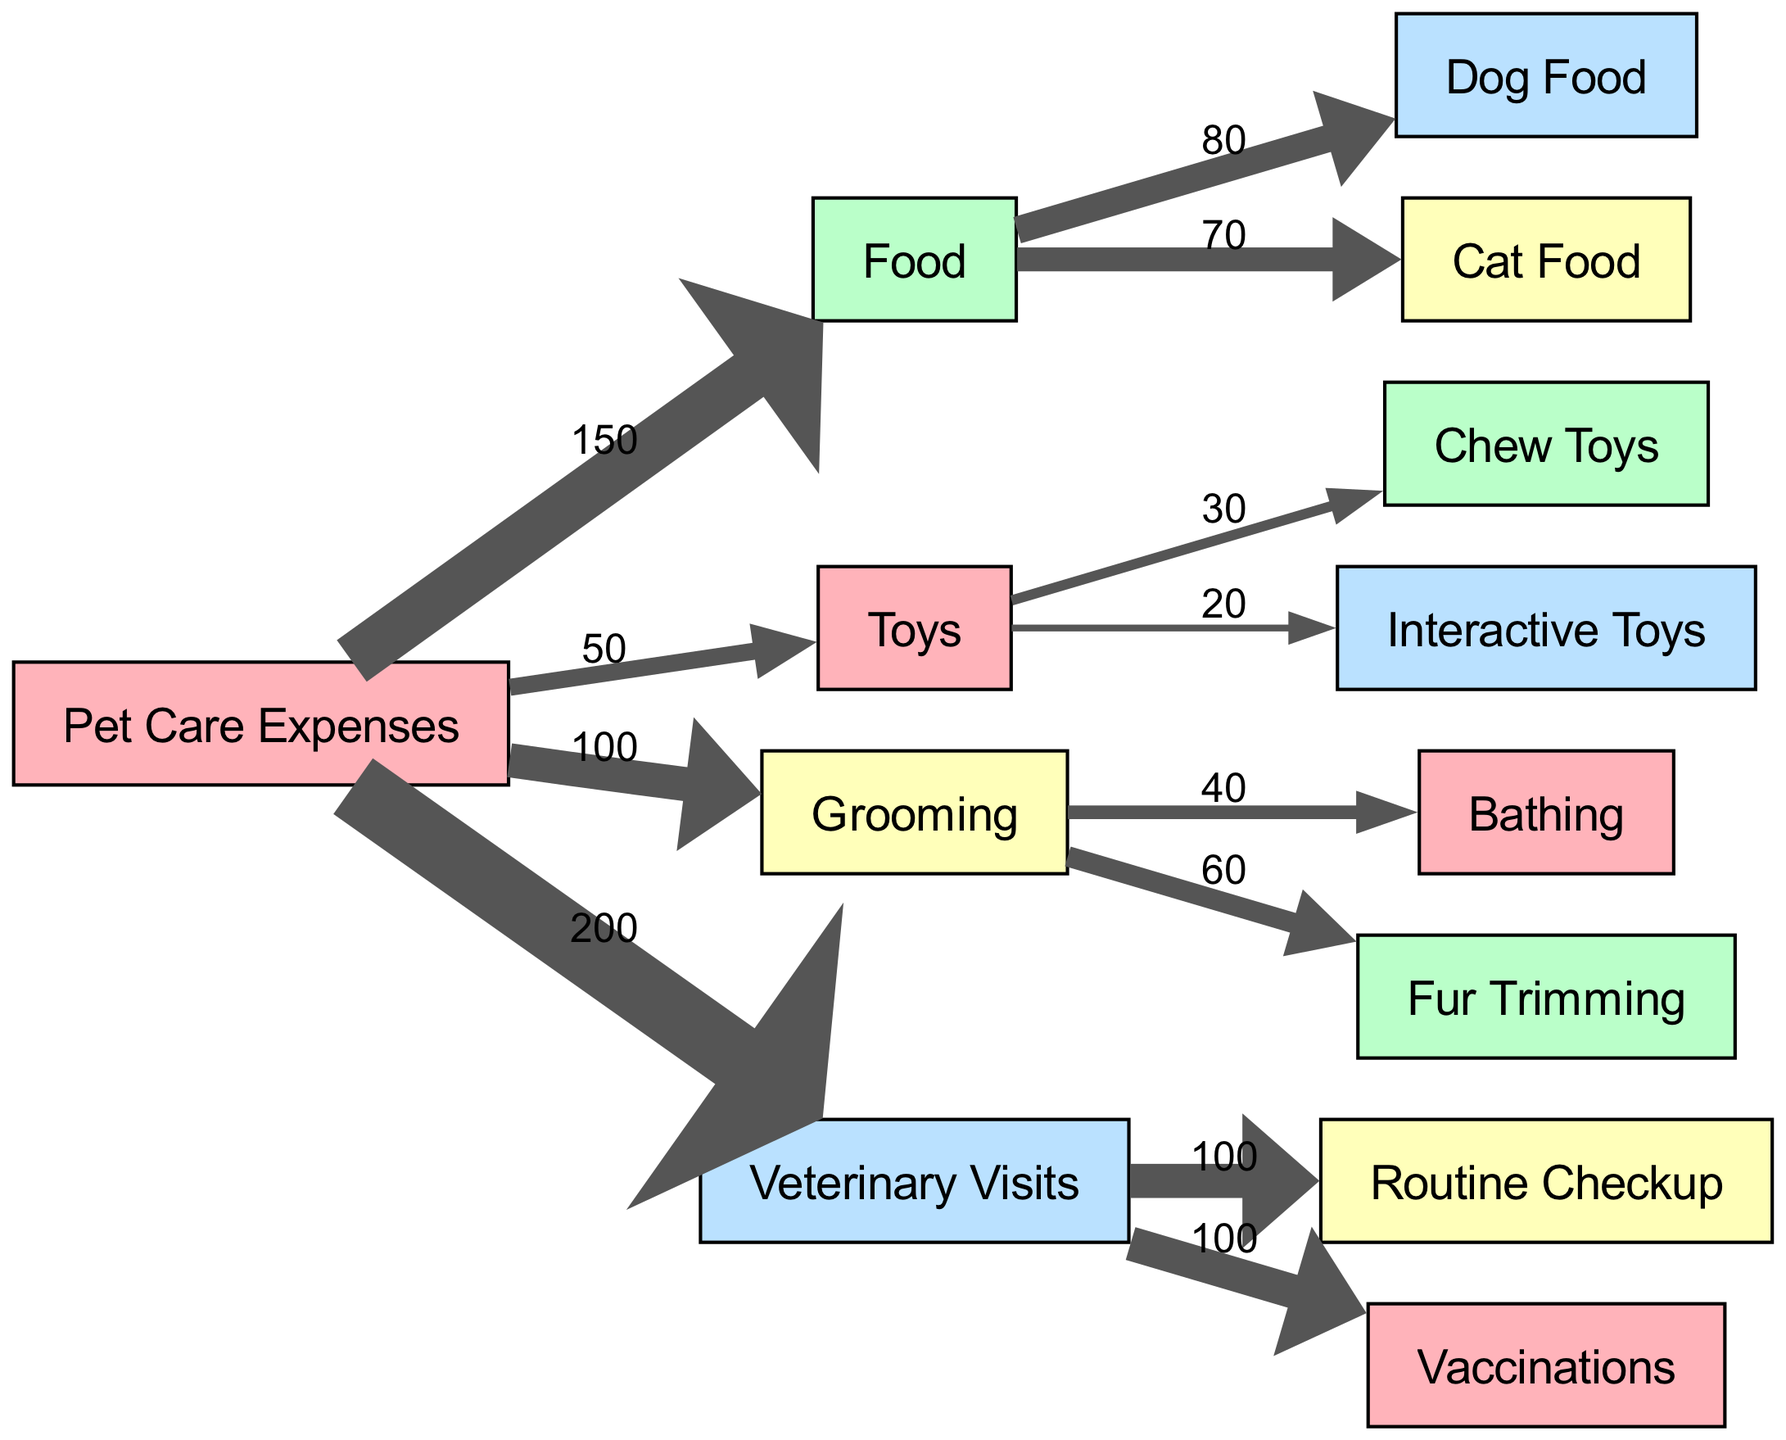What is the total amount spent on Food? The diagram states that the amount spent on Food is 150, which is indicated as a direct flow from "Pet Care Expenses" to "Food".
Answer: 150 How much was spent specifically on Dog Food? The amount allocated to Dog Food is shown to be 80, directly linked from "Food" to "Dog Food".
Answer: 80 What are the total expenses for Veterinary Visits? According to the diagram, the total expenses for Veterinary Visits is 200, noted as a direct link from "Pet Care Expenses" to "Veterinary Visits".
Answer: 200 How many types of Toys are represented in the diagram? The diagram lists two types of Toys (Chew Toys and Interactive Toys) that are linked under the main "Toys" category, which means there are 2 types.
Answer: 2 What is the amount spent on Fur Trimming? The Fur Trimming expense is indicated to be 60, derived from the Grooming category which connects to Fur Trimming.
Answer: 60 Which category has the highest expense? By evaluating the main expenses, Veterinary Visits (200) has the highest amount compared to Food (150), Toys (50), and Grooming (100).
Answer: Veterinary Visits What is the combined cost of Grooming services (Bathing and Fur Trimming)? Bathing costs 40 and Fur Trimming costs 60, totaling 100 when combined. This is shown by direct links from Grooming to each respective service.
Answer: 100 What percentage of Pet Care Expenses is allocated to Toys? The total Pet Care Expenses is 500 (sum of all individual categories), while Toys account for 50. Therefore, the percentage is (50/500) * 100 = 10%.
Answer: 10% Which category receives equal spending on both Routine Checkup and Vaccinations? The total spending on both Routine Checkup and Vaccinations is 100 each, showing that the Veterinary Visits category has equal allocation for these two services.
Answer: Equal spending 